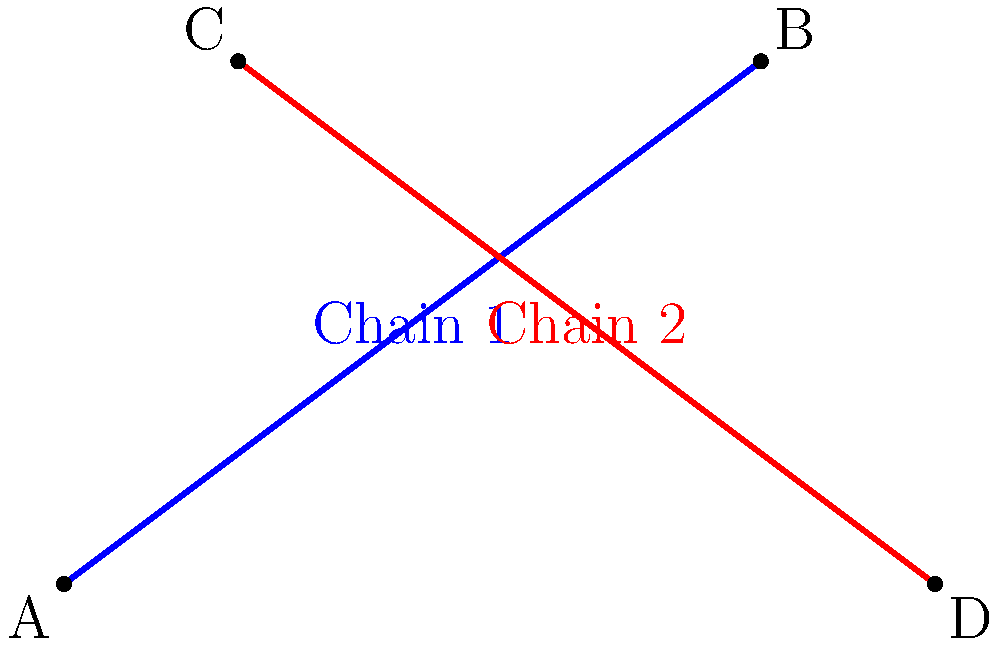A vintage necklace features two intersecting chains. Chain 1 passes through points A(0,0) and B(4,3), while Chain 2 passes through points C(1,3) and D(5,0). Calculate the angle of intersection between these two chains. To find the angle between the two chains, we'll follow these steps:

1. Calculate the slopes of both chains:
   
   For Chain 1: $m_1 = \frac{y_B - y_A}{x_B - x_A} = \frac{3 - 0}{4 - 0} = \frac{3}{4}$
   
   For Chain 2: $m_2 = \frac{y_D - y_C}{x_D - x_C} = \frac{0 - 3}{5 - 1} = -\frac{3}{4}$

2. Use the formula for the angle between two lines:
   
   $\tan \theta = |\frac{m_2 - m_1}{1 + m_1m_2}|$

3. Substitute the slopes:
   
   $\tan \theta = |\frac{(-\frac{3}{4}) - (\frac{3}{4})}{1 + (\frac{3}{4})(-\frac{3}{4})}| = |\frac{-\frac{3}{2}}{1 - \frac{9}{16}}| = |\frac{-\frac{24}{16}}{\frac{7}{16}}| = \frac{24}{7}$

4. Calculate the angle using inverse tangent:
   
   $\theta = \arctan(\frac{24}{7}) \approx 73.74°$

5. Round to the nearest degree:
   
   $\theta \approx 74°$
Answer: $74°$ 